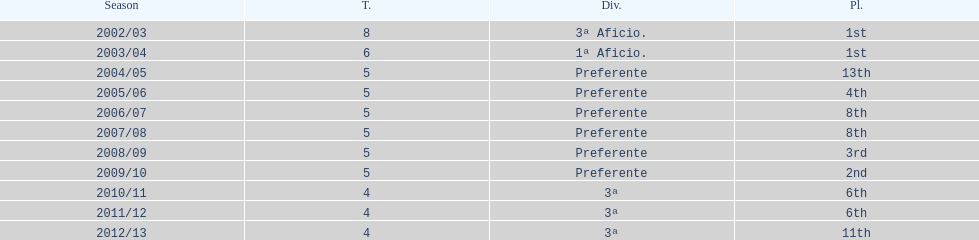How long did the team stay in first place? 2 years. 